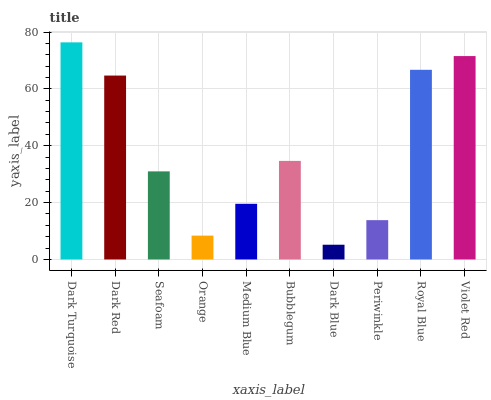Is Dark Blue the minimum?
Answer yes or no. Yes. Is Dark Turquoise the maximum?
Answer yes or no. Yes. Is Dark Red the minimum?
Answer yes or no. No. Is Dark Red the maximum?
Answer yes or no. No. Is Dark Turquoise greater than Dark Red?
Answer yes or no. Yes. Is Dark Red less than Dark Turquoise?
Answer yes or no. Yes. Is Dark Red greater than Dark Turquoise?
Answer yes or no. No. Is Dark Turquoise less than Dark Red?
Answer yes or no. No. Is Bubblegum the high median?
Answer yes or no. Yes. Is Seafoam the low median?
Answer yes or no. Yes. Is Seafoam the high median?
Answer yes or no. No. Is Royal Blue the low median?
Answer yes or no. No. 